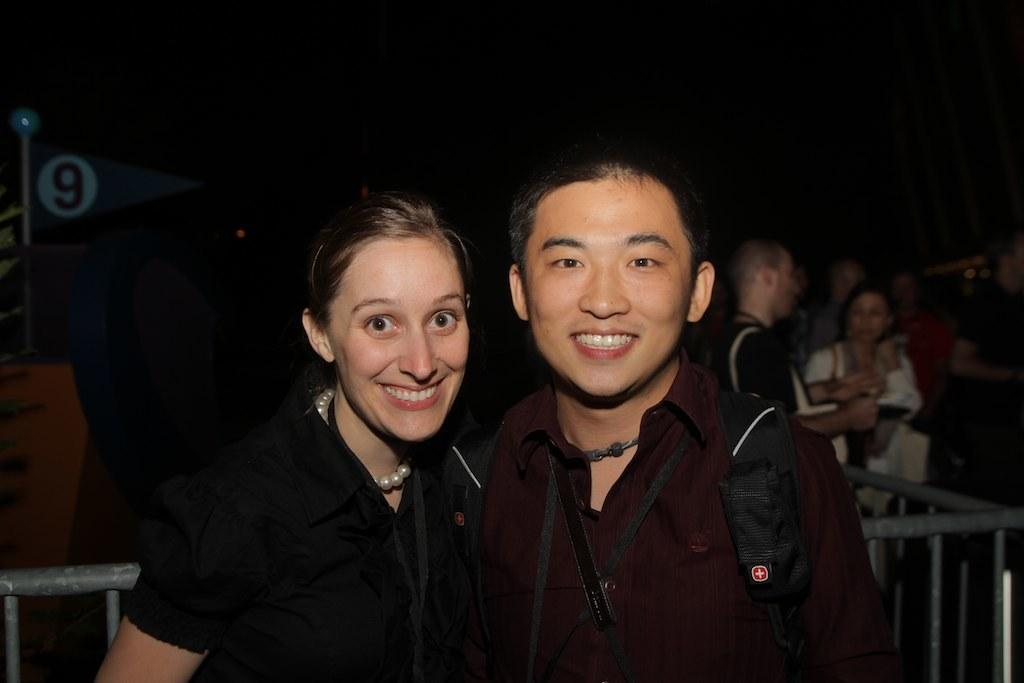Who are the main subjects in the image? There is a man and a lady in the center of the image. What are the man and the lady doing in the image? The man and the lady are standing and smiling. Can you describe the background of the image? There are people in the background of the image. What is at the bottom of the image? There is a railing at the bottom of the image. What type of nail is being used by the man in the image? There is no nail present in the image; the man and the lady are simply standing and smiling. 